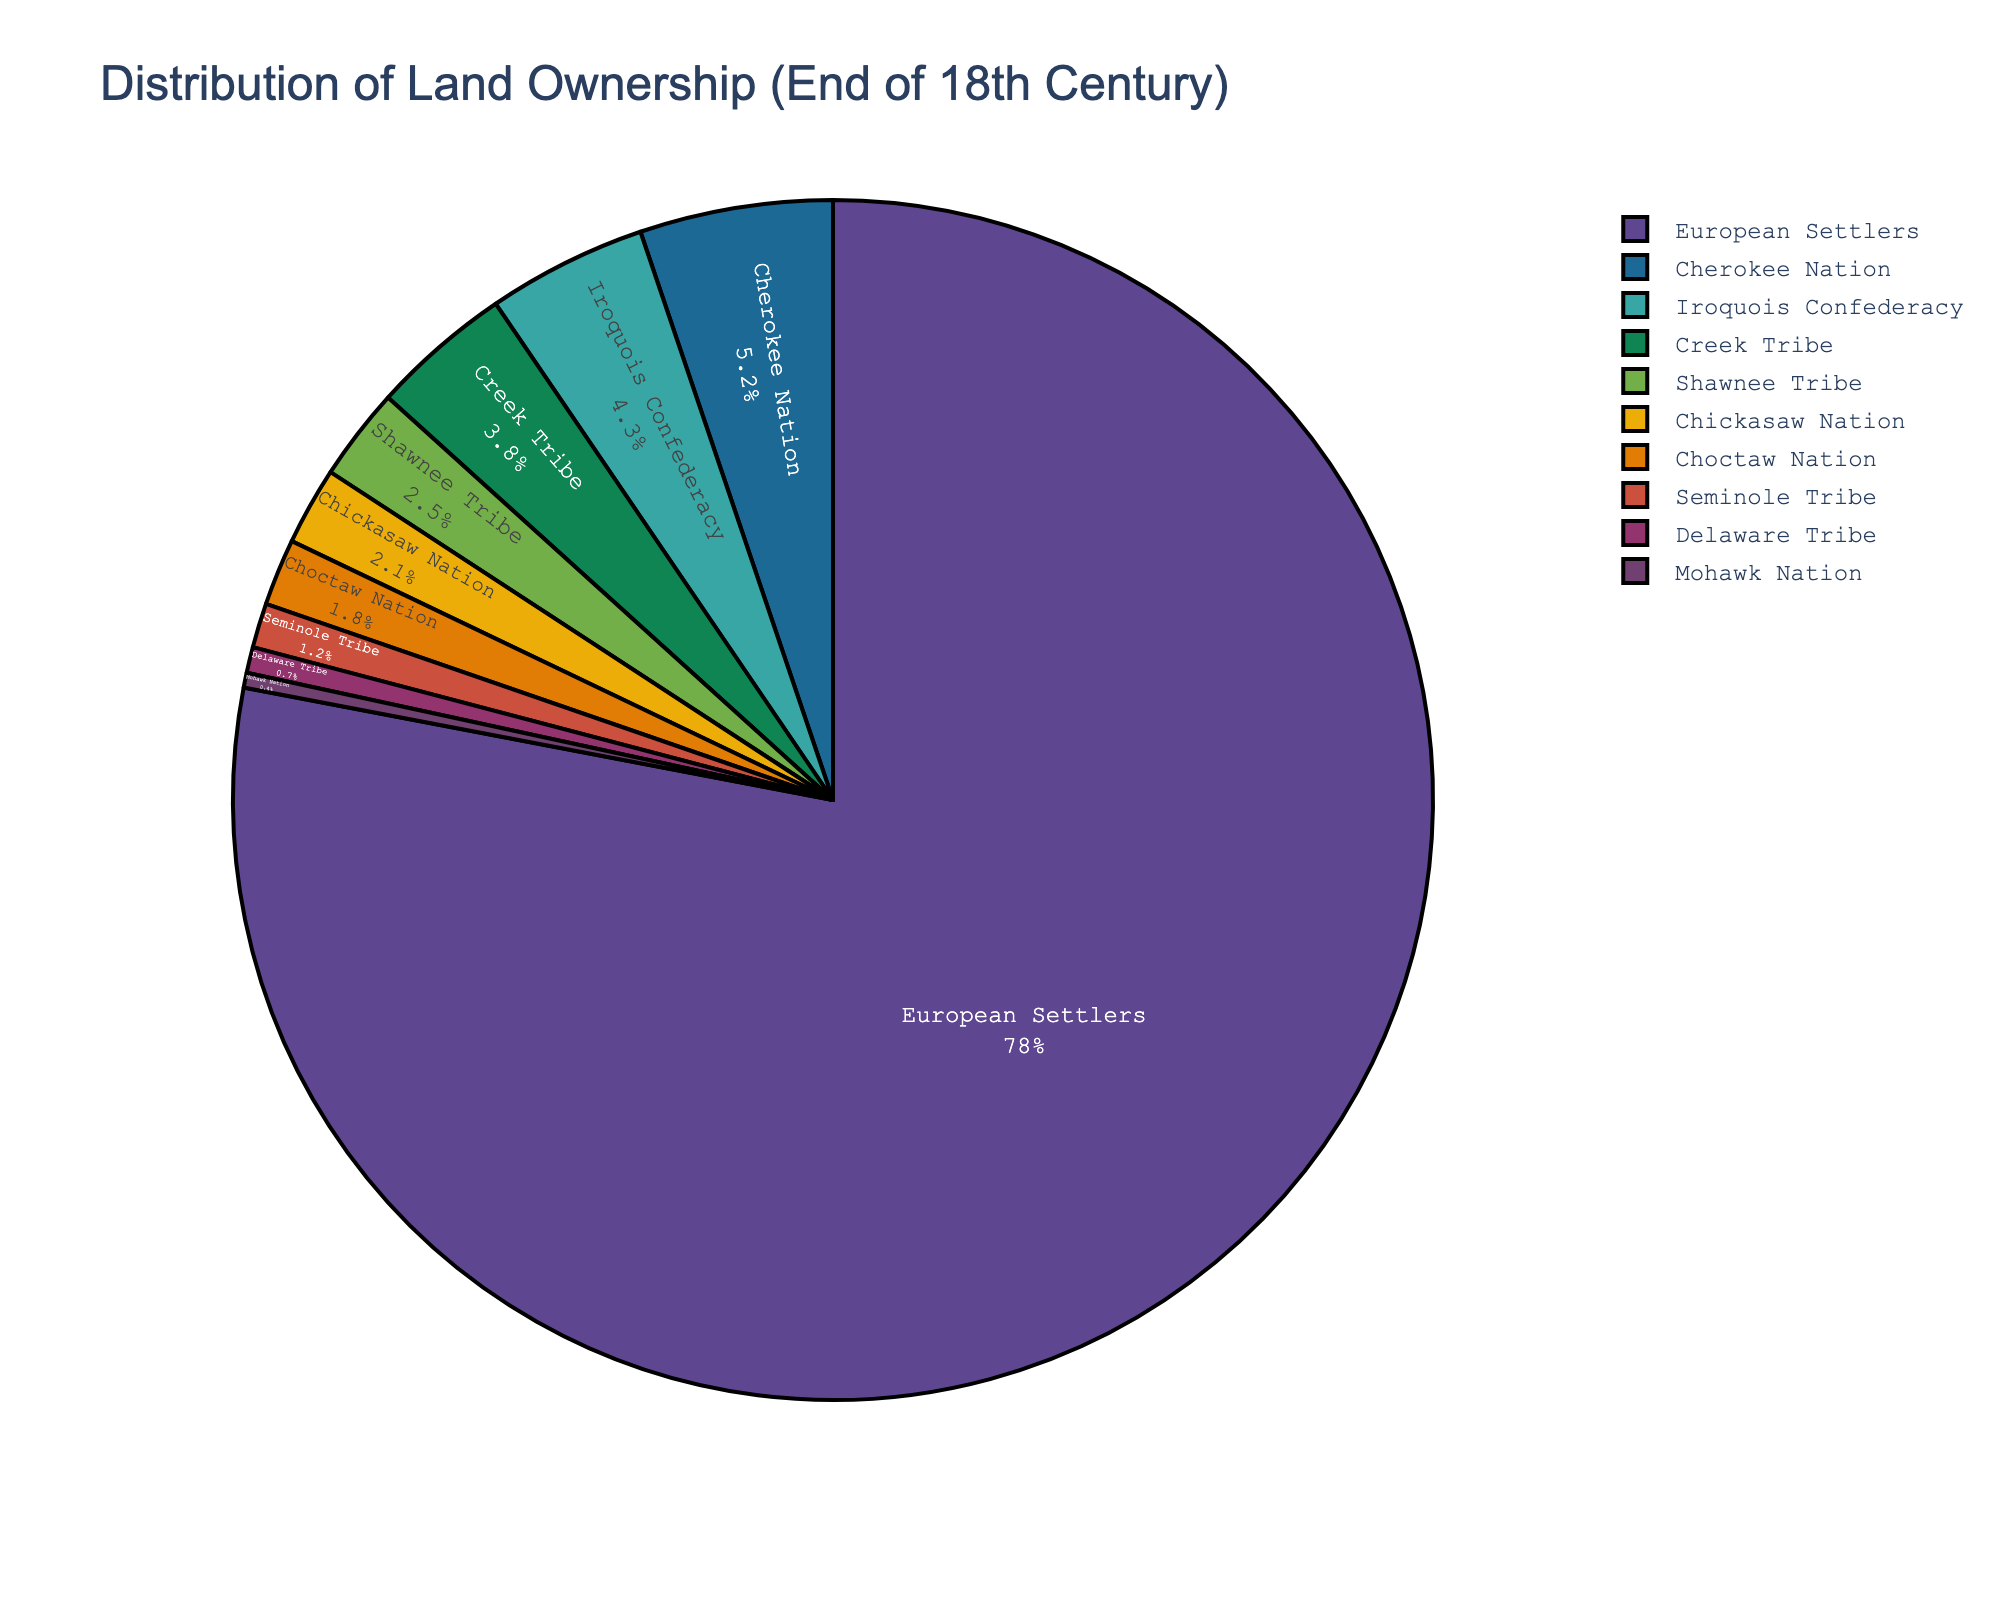Which group has the highest land ownership percentage? By observing the figure, it's clear that the largest segment belongs to European Settlers.
Answer: European Settlers What are the combined percentages of land ownership for the Cherokee Nation and the Iroquois Confederacy? Summing the percentages of the Cherokee Nation (5.2) and the Iroquois Confederacy (4.3), we get 5.2 + 4.3 = 9.5.
Answer: 9.5 Which Native American tribe has the smallest land ownership percentage? By looking for the smallest segment among the Native American tribes, we can see that the Mohawk Nation has the smallest percentage (0.4).
Answer: Mohawk Nation What is the difference in land ownership percentage between the Creek Tribe and the Shawnee Tribe? The land ownership percentage of the Creek Tribe is 3.8, and for the Shawnee Tribe, it is 2.5. The difference is 3.8 - 2.5 = 1.3.
Answer: 1.3 What is the total land ownership percentage of the Choctaw Nation and the Chickasaw Nation? The percentage for the Choctaw Nation is 1.8, and for the Chickasaw Nation, it is 2.1. Adding these gives 1.8 + 2.1 = 3.9.
Answer: 3.9 Is the land ownership percentage of the European Settlers more than ten times that of the Cherokee Nation? The percentage for the European Settlers is 78, and for the Cherokee Nation, it is 5.2. Ten times the Cherokee Nation's percentage is 5.2 x 10 = 52. Since 78 > 52, the European Settlers' percentage is more than ten times that of the Cherokee Nation.
Answer: Yes Which two Native American tribes together own more than 8% of the land? The Cherokee Nation owns 5.2% and the Iroquois Confederacy owns 4.3%. Summing these gives 5.2 + 4.3 = 9.5, which is more than 8%.
Answer: Cherokee Nation and Iroquois Confederacy How does the percentage of land owned by the Seminole Tribe compare to that of the Delaware Tribe? The Seminole Tribe has a land ownership percentage of 1.2, whereas the Delaware Tribe has 0.7. Thus, the Seminole Tribe owns a larger percentage of land compared to the Delaware Tribe.
Answer: Seminole Tribe has more What is the average land ownership percentage of the four tribes with the lowest percentages? The four tribes with the lowest percentages are: Delaware Tribe (0.7), Mohawk Nation (0.4), Seminole Tribe (1.2), and Choctaw Nation (1.8). The sum is 0.7 + 0.4 + 1.2 + 1.8 = 4.1. Dividing by 4, the average is 4.1 / 4 = 1.025.
Answer: 1.025 